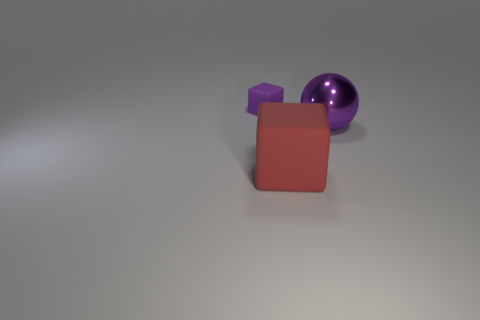What color is the shiny sphere?
Keep it short and to the point. Purple. Is the color of the matte block that is in front of the purple rubber cube the same as the thing that is behind the purple shiny thing?
Ensure brevity in your answer.  No. There is another object that is the same shape as the red thing; what is its size?
Your answer should be very brief. Small. Is there a object that has the same color as the small block?
Provide a short and direct response. Yes. What material is the ball that is the same color as the small rubber block?
Your answer should be compact. Metal. What number of large balls have the same color as the large cube?
Your answer should be compact. 0. What number of objects are either matte objects that are to the right of the tiny purple matte block or large red rubber cubes?
Your answer should be very brief. 1. What color is the large cube that is made of the same material as the tiny thing?
Keep it short and to the point. Red. Are there any yellow metallic cylinders that have the same size as the metallic sphere?
Make the answer very short. No. How many things are either objects that are in front of the small block or objects that are left of the sphere?
Keep it short and to the point. 3. 